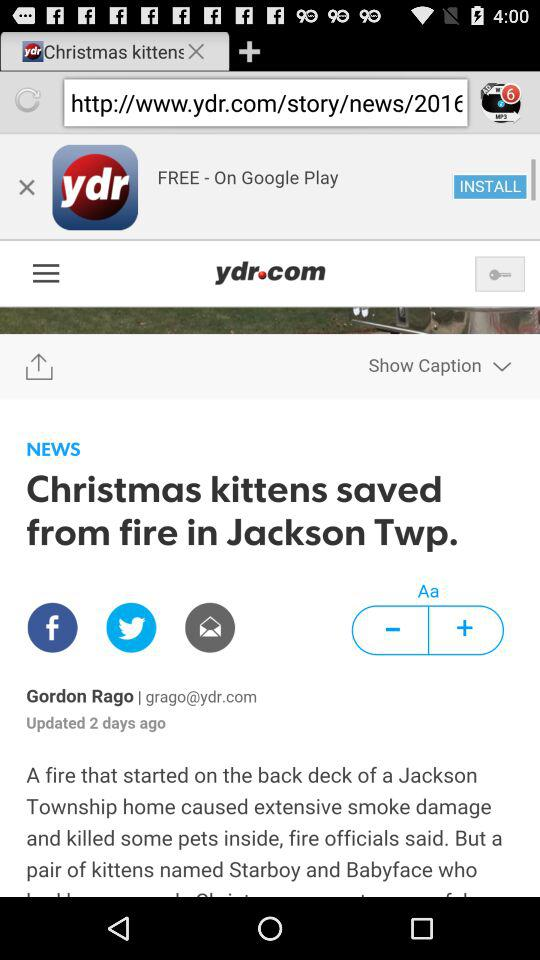What is the headline of the news? The headline of the news is "Christmas kittens saved from fire in Jackson Twp". 